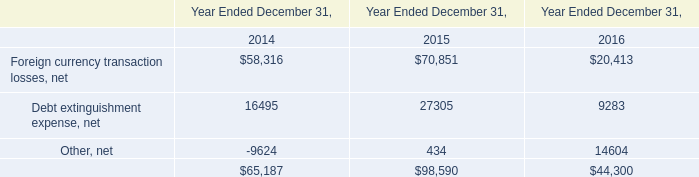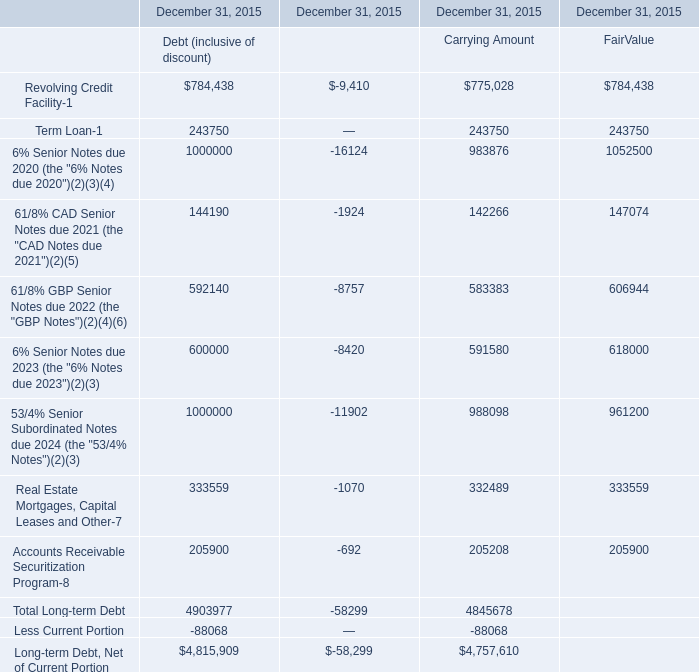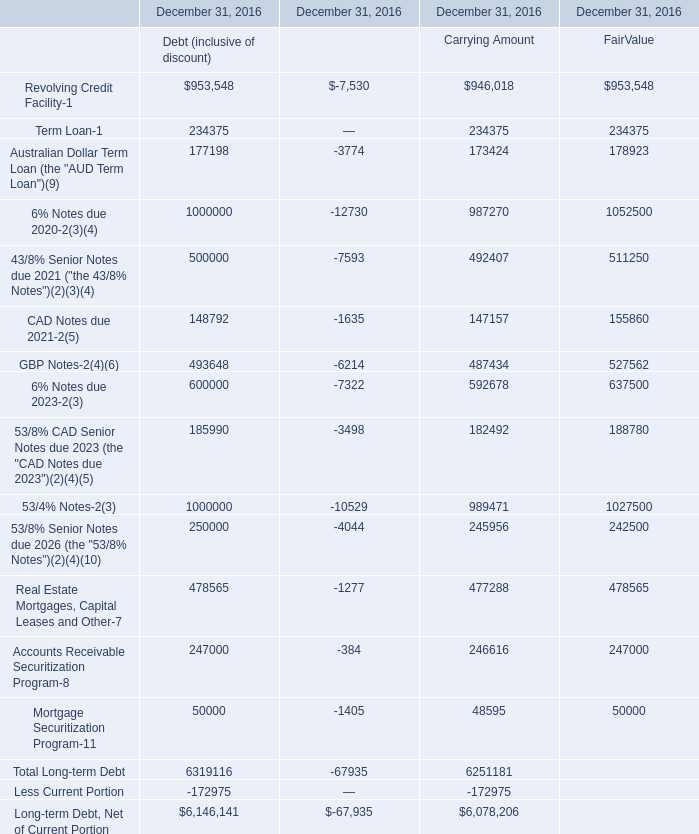What is the average value of CAD Notes due 2021-2(5) for Carrying Amount and Debt extinguishment expense, net in 2016? 
Computations: ((147157 + 9283) / 2)
Answer: 78220.0. 